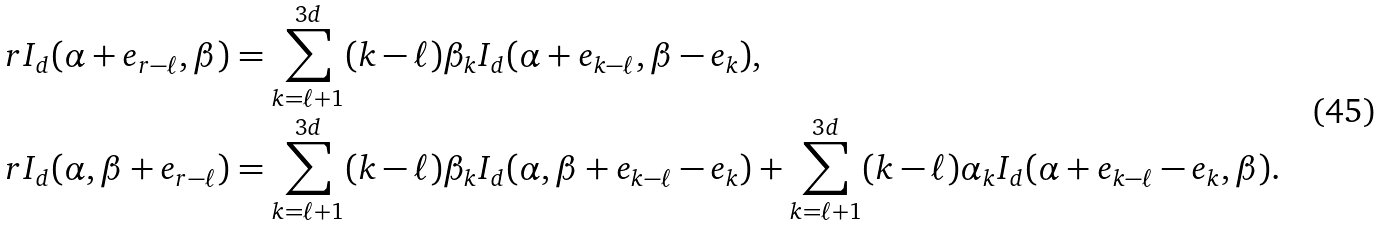Convert formula to latex. <formula><loc_0><loc_0><loc_500><loc_500>r I _ { d } ( \alpha + e _ { r - \ell } , \beta ) & = \sum _ { k = \ell + 1 } ^ { 3 d } ( k - \ell ) \beta _ { k } I _ { d } ( \alpha + e _ { k - \ell } , \beta - e _ { k } ) , \\ r I _ { d } ( \alpha , \beta + e _ { r - \ell } ) & = \sum _ { k = \ell + 1 } ^ { 3 d } ( k - \ell ) \beta _ { k } I _ { d } ( \alpha , \beta + e _ { k - \ell } - e _ { k } ) + \sum _ { k = \ell + 1 } ^ { 3 d } ( k - \ell ) \alpha _ { k } I _ { d } ( \alpha + e _ { k - \ell } - e _ { k } , \beta ) .</formula> 